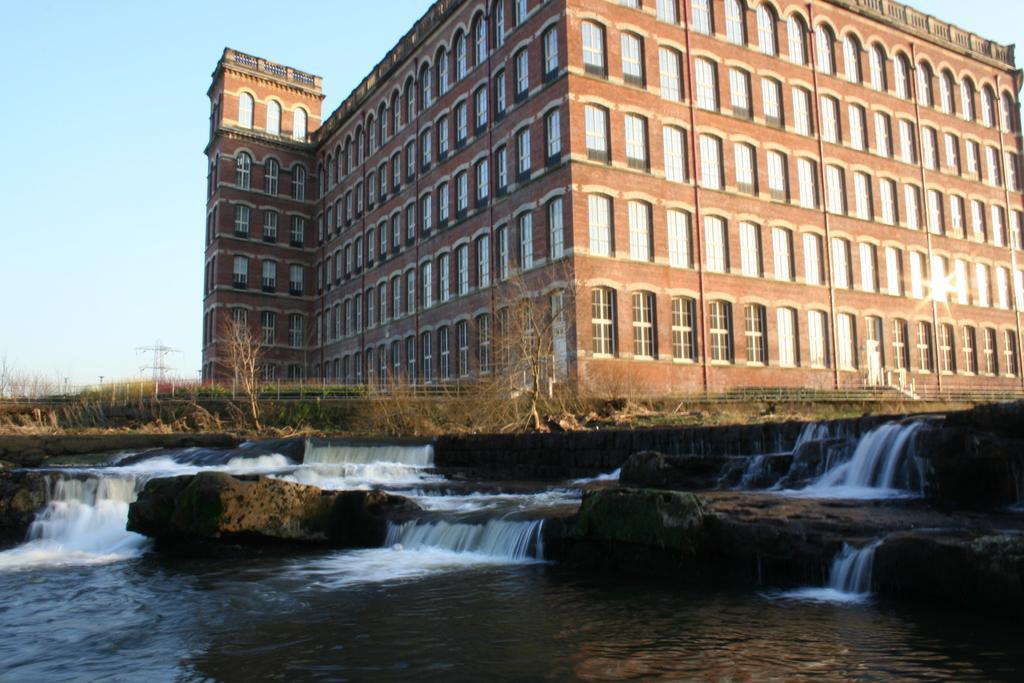How would you summarize this image in a sentence or two? In this image at the bottom, there are waterfalls, water, stones, grass and plants. In the middle there is a building on that there are windows and wall. On the right there are transmission lines and sky. 